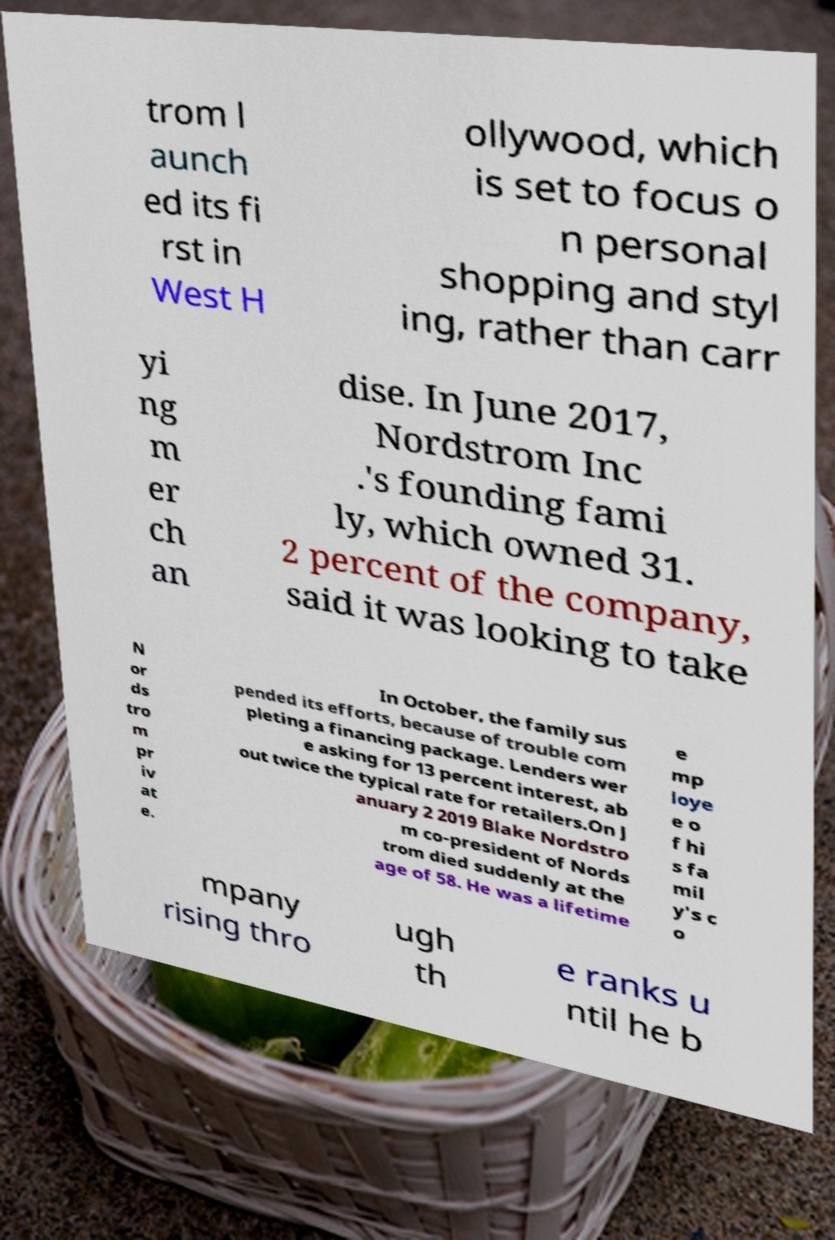Please identify and transcribe the text found in this image. trom l aunch ed its fi rst in West H ollywood, which is set to focus o n personal shopping and styl ing, rather than carr yi ng m er ch an dise. In June 2017, Nordstrom Inc .'s founding fami ly, which owned 31. 2 percent of the company, said it was looking to take N or ds tro m pr iv at e. In October, the family sus pended its efforts, because of trouble com pleting a financing package. Lenders wer e asking for 13 percent interest, ab out twice the typical rate for retailers.On J anuary 2 2019 Blake Nordstro m co-president of Nords trom died suddenly at the age of 58. He was a lifetime e mp loye e o f hi s fa mil y's c o mpany rising thro ugh th e ranks u ntil he b 